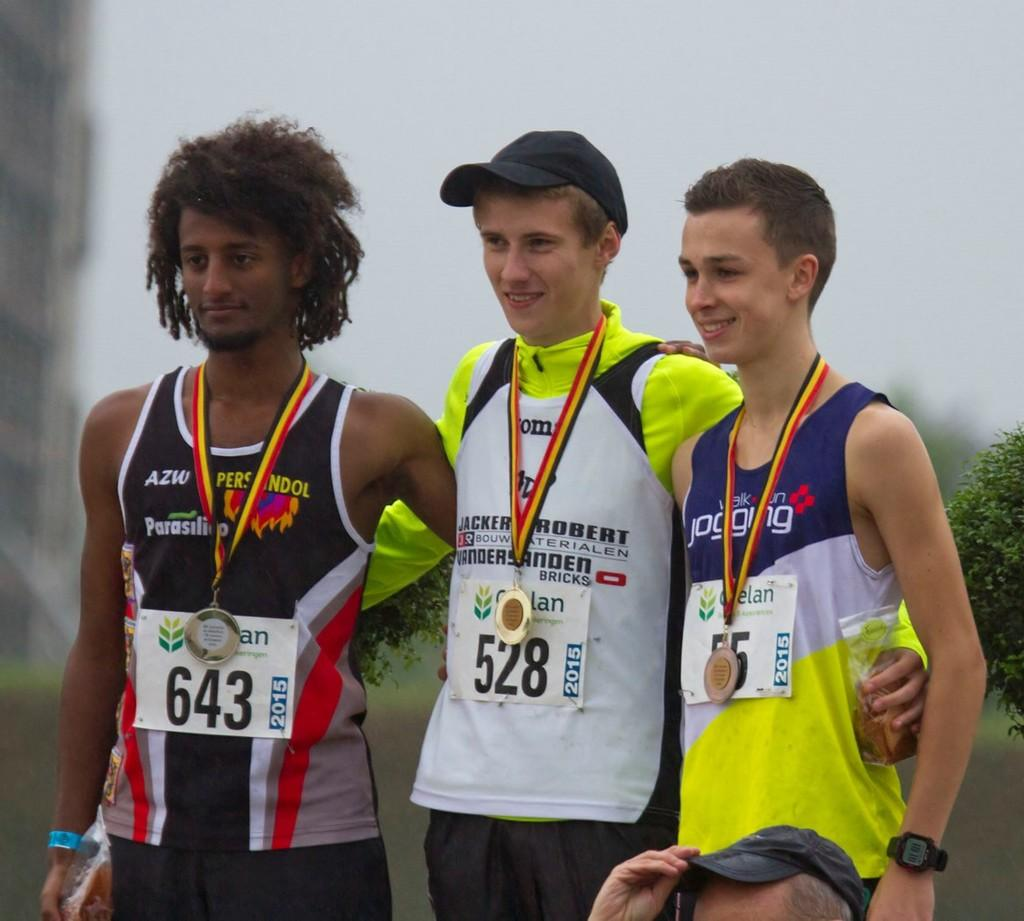<image>
Write a terse but informative summary of the picture. A competitor wears number 643 while posing with his opponents. 